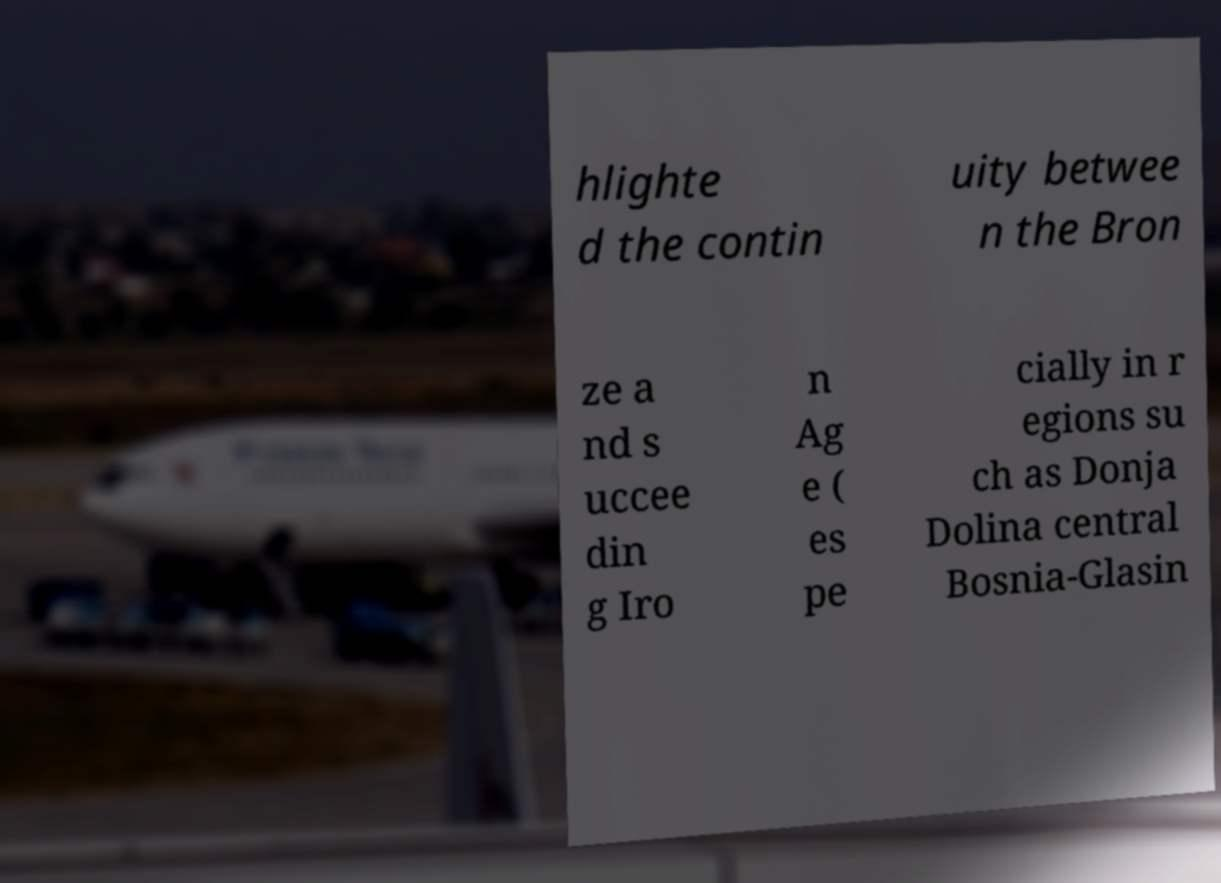Please identify and transcribe the text found in this image. hlighte d the contin uity betwee n the Bron ze a nd s uccee din g Iro n Ag e ( es pe cially in r egions su ch as Donja Dolina central Bosnia-Glasin 